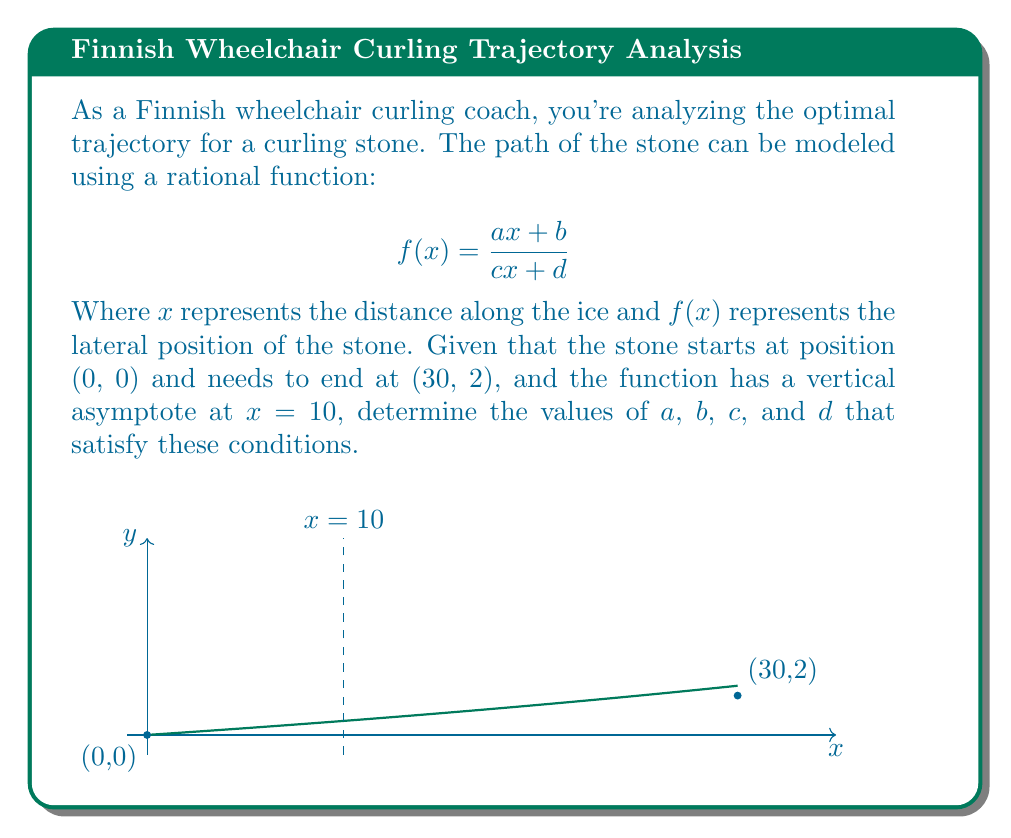Provide a solution to this math problem. Let's approach this step-by-step:

1) Since the stone starts at (0, 0), we know that $f(0) = 0$. This means:
   $$f(0) = \frac{a(0) + b}{c(0) + d} = \frac{b}{d} = 0$$
   This is only possible if $b = 0$ (assuming $d \neq 0$).

2) The vertical asymptote at $x = 10$ means that the denominator equals zero when $x = 10$:
   $$c(10) + d = 0$$
   $$10c + d = 0$$

3) The stone ends at (30, 2), so $f(30) = 2$:
   $$f(30) = \frac{a(30)}{c(30) + d} = 2$$

4) Now we have a system of equations:
   $$b = 0$$
   $$10c + d = 0$$
   $$\frac{30a}{30c + d} = 2$$

5) From the second equation: $d = -10c$

6) Substituting this into the third equation:
   $$\frac{30a}{30c - 10c} = 2$$
   $$\frac{30a}{20c} = 2$$
   $$\frac{3a}{2c} = 2$$
   $$3a = 4c$$

7) We can choose $c = 3$ and $a = 4$ to satisfy this equation.

8) If $c = 3$, then $d = -10c = -30$

Therefore, one possible solution is:
$a = 4$, $b = 0$, $c = 3$, and $d = -30$

The resulting function is:
$$f(x) = \frac{4x}{3x - 30}$$
Answer: $a = 4$, $b = 0$, $c = 3$, $d = -30$ 